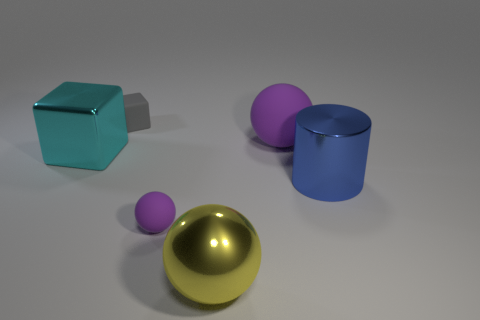Subtract all big spheres. How many spheres are left? 1 Add 4 shiny spheres. How many objects exist? 10 Subtract all yellow spheres. How many spheres are left? 2 Subtract all cubes. How many objects are left? 4 Subtract 3 spheres. How many spheres are left? 0 Subtract all purple cubes. How many red cylinders are left? 0 Subtract all cubes. Subtract all purple things. How many objects are left? 2 Add 5 gray cubes. How many gray cubes are left? 6 Add 4 tiny brown metallic blocks. How many tiny brown metallic blocks exist? 4 Subtract 0 red balls. How many objects are left? 6 